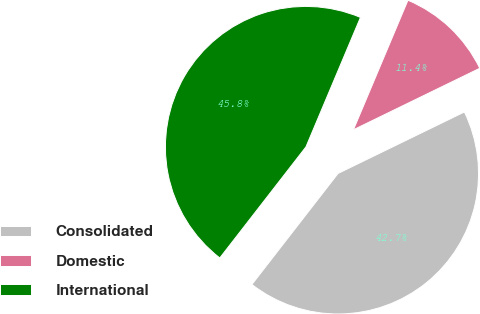<chart> <loc_0><loc_0><loc_500><loc_500><pie_chart><fcel>Consolidated<fcel>Domestic<fcel>International<nl><fcel>42.71%<fcel>11.45%<fcel>45.84%<nl></chart> 